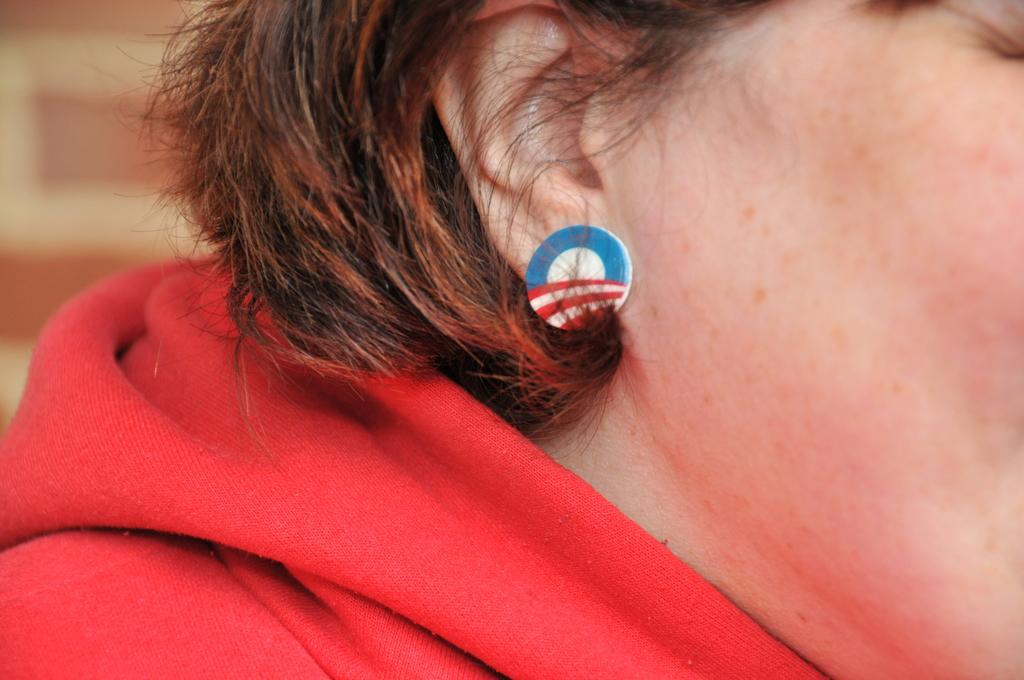What is the main subject of the image? There is a person in the image. What is the person wearing? The person is wearing a red dress and earrings. Can you describe the background of the image? The background of the image is blurred. What type of stew is being served in the image? There is no stew present in the image; it features a person wearing a red dress and earrings. What time does the clock in the image show? There is no clock present in the image. 